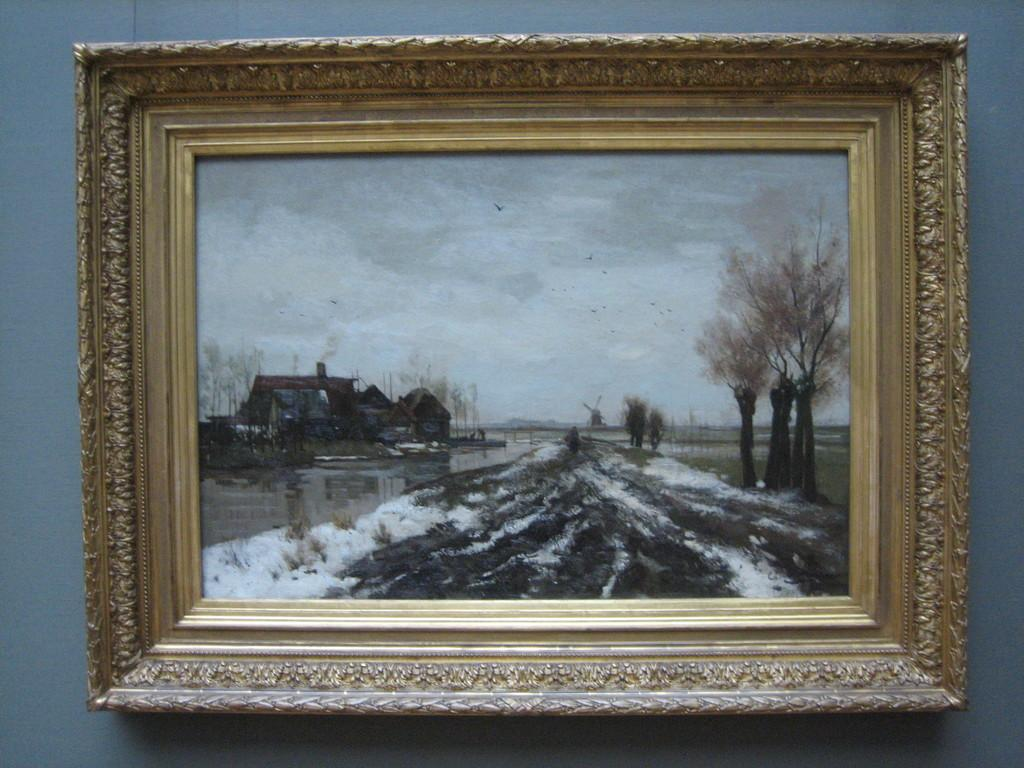What object is hanging on the wall in the image? There is a photo frame in the image, and it is hanged on a wall. What is displayed within the photo frame? The photo frame contains an image of a house. What additional features can be seen in the image within the photo frame? The image in the photo frame includes trees and depicts snow. How much does the side of the house in the photo frame weigh? The weight of the side of the house in the photo frame cannot be determined from the image, as it is a two-dimensional representation. 